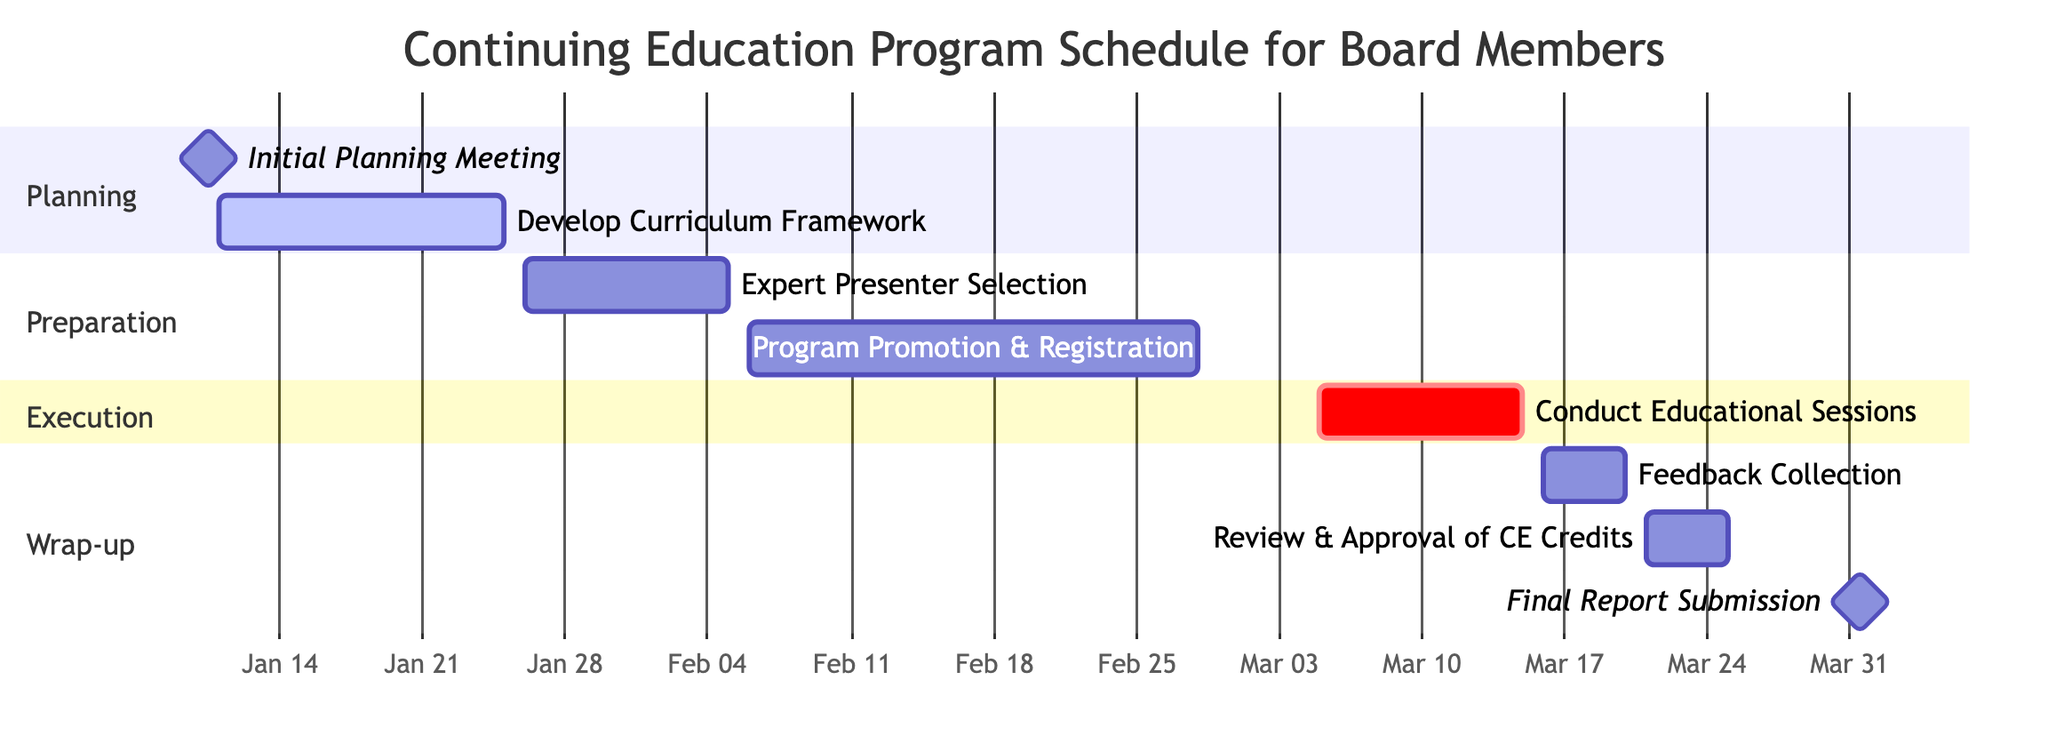What is the duration of the "Develop Curriculum Framework" task? The "Develop Curriculum Framework" task starts on January 11, 2024, and ends on January 25, 2024. To find the duration, we count the days from the start date to the end date, inclusive. This gives us 15 days as the duration.
Answer: 15 days Which task follows "Program Promotion & Registration"? In the Gantt chart, "Program Promotion & Registration" ends on February 28, 2024. The next task that starts after this is "Conduct Educational Sessions," which begins on March 5, 2024. Therefore, the task that follows is "Conduct Educational Sessions."
Answer: Conduct Educational Sessions How many tasks are in the "Wrap-up" section? In the Gantt chart, the "Wrap-up" section includes three tasks: "Feedback Collection," "Review & Approval of CE Credits," and "Final Report Submission." Counting these tasks gives us a total of three.
Answer: 3 What is the earliest start date among all tasks? The earliest start date is found by looking at all task start dates. The earliest task is "Initial Planning Meeting," which starts on January 10, 2024.
Answer: January 10, 2024 Which task has the longest duration? By analyzing the tasks and their durations, "Program Promotion & Registration" runs from February 6 to February 28, which calculates to 22 days. This is the longest duration compared to other tasks.
Answer: Program Promotion & Registration 